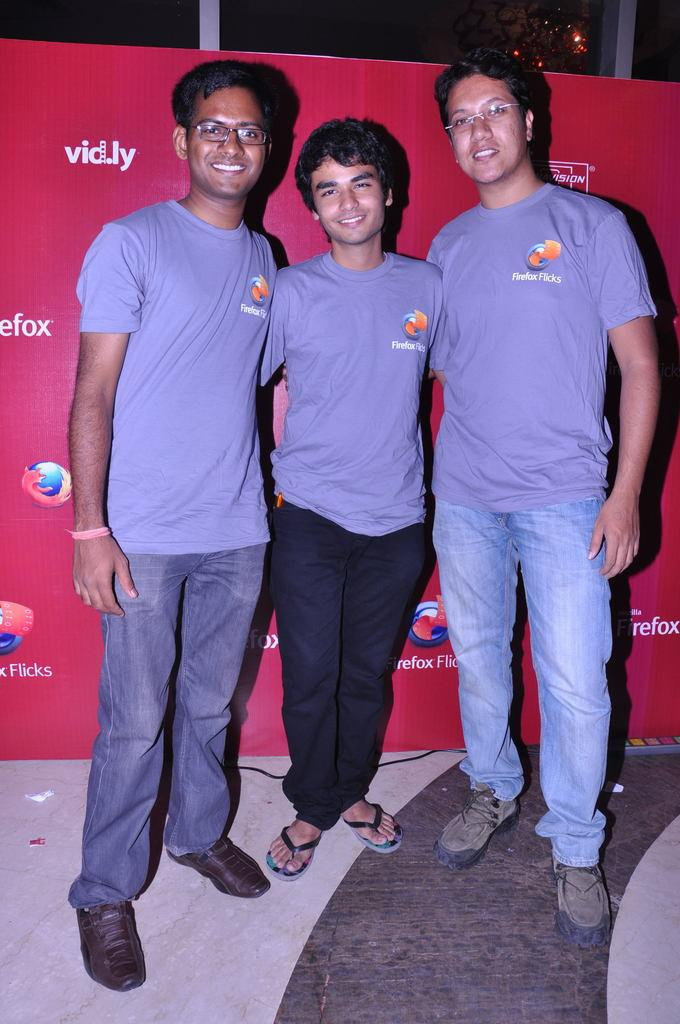What can be seen in the image involving people? There are people standing in the image. Where are the people standing? The people are standing on the floor. What is present in the image besides the people? There is a banner with text and a logo in the image. What can be seen in the background of the image? There appears to be a window in the background of the image. How many kittens are playing with the banner in the image? There are no kittens present in the image; it only features people standing and a banner. What is the weight of the window in the image? The weight of the window cannot be determined from the image, as it only provides a visual representation and not physical measurements. 